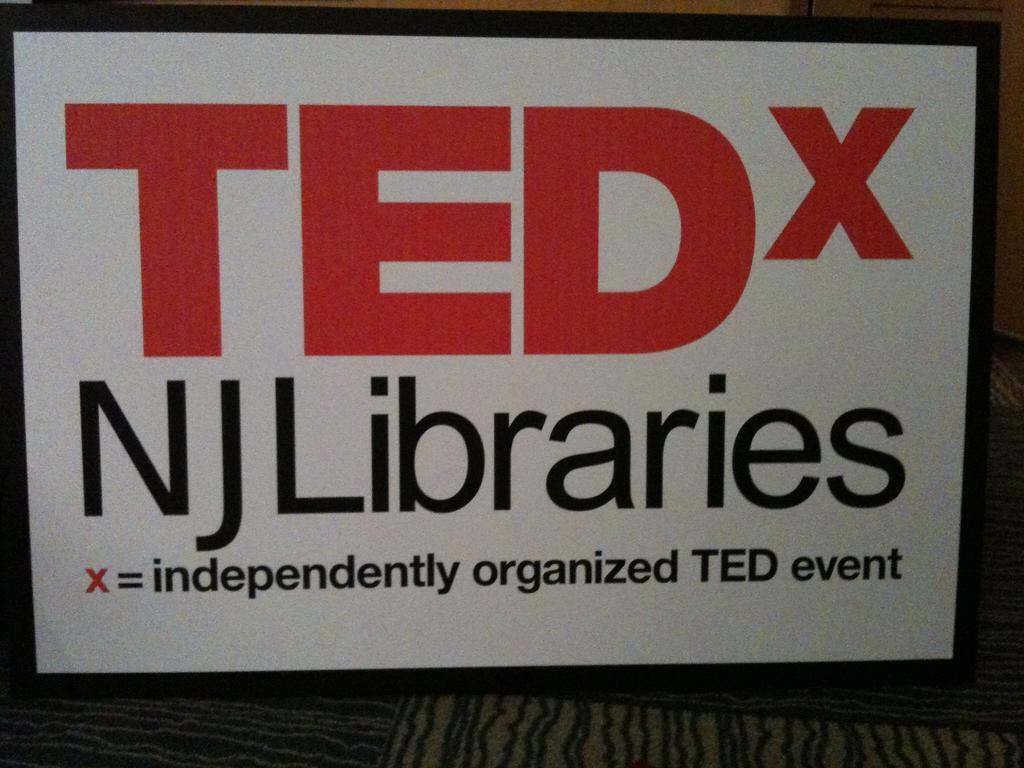<image>
Relay a brief, clear account of the picture shown. A TEDx event has been organized by NJ Libraries. 